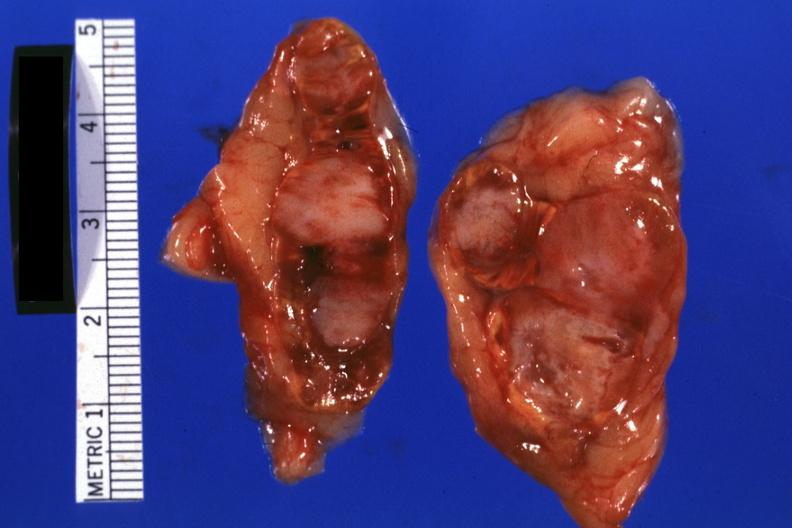s metastatic carcinoma lung present?
Answer the question using a single word or phrase. Yes 